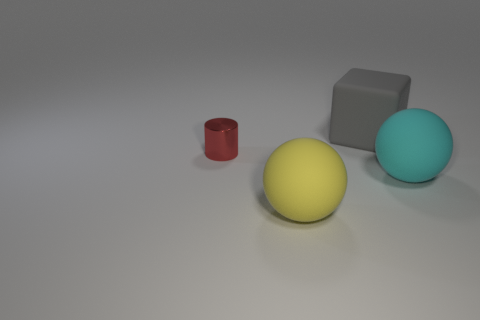Is there any indication of the size or scale of these objects? There is no definitive indicator of size or scale within the image as there are no familiar objects or reference points to compare them against. Without additional context, it is challenging to determine their actual size; they could range from miniature models to sizable real-world objects. 